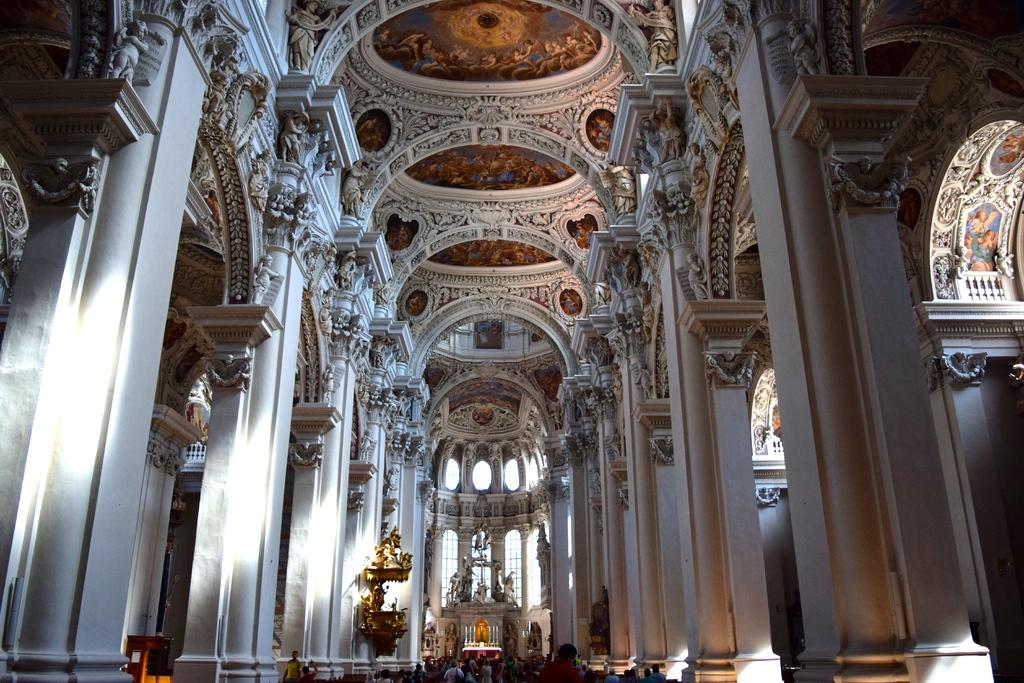What can be seen on top of the pillars in the image? There are sculptures on pillars in the image. What is present at the bottom of the image? There is a crowd at the bottom of the image. What color is the blood spilled on the ground in the image? There is no blood spilled on the ground in the image. Where is the park located in the image? The provided facts do not mention a park, so it cannot be determined from the image. 